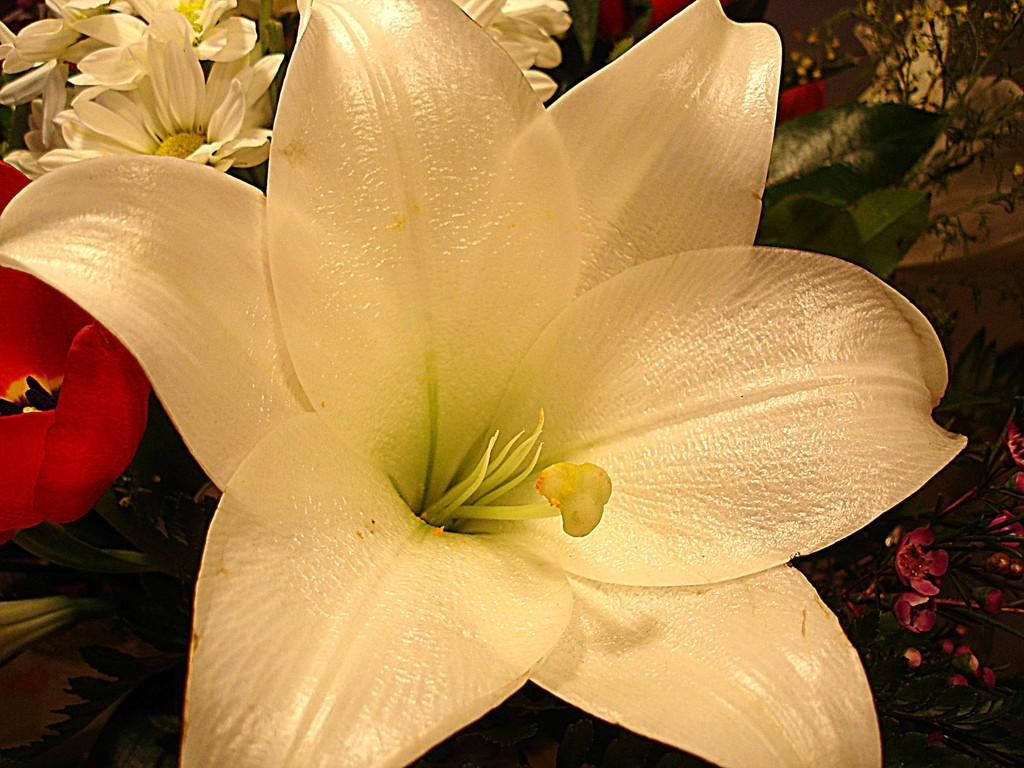What is the main subject of the image? There is a flower in the image. Are there any other flowers in the image besides the main one? Yes, there are other flowers behind the main flower. What else can be seen in the image besides flowers? There are plants visible in the image. What is the nut's tendency to stick to the tongue in the image? There is no nut present in the image, and therefore no such interaction can be observed. 